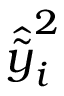Convert formula to latex. <formula><loc_0><loc_0><loc_500><loc_500>\hat { \widetilde { y } } _ { i } ^ { 2 }</formula> 